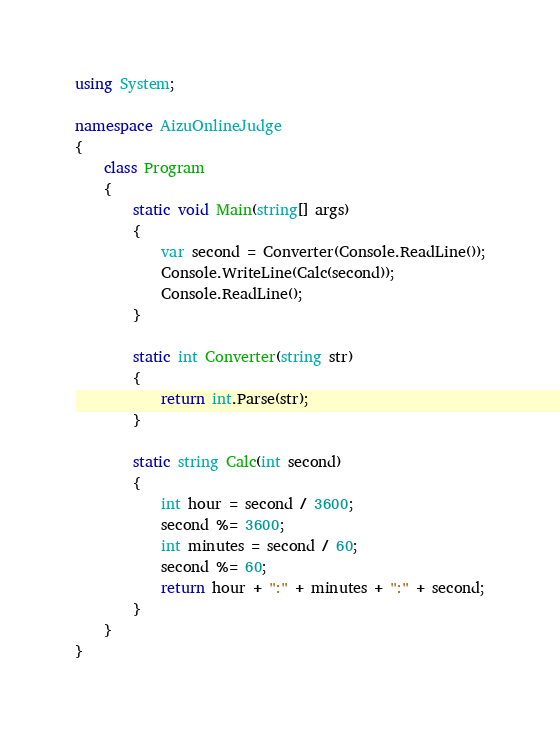Convert code to text. <code><loc_0><loc_0><loc_500><loc_500><_C#_>using System;

namespace AizuOnlineJudge
{
    class Program
    {
        static void Main(string[] args)
        {
            var second = Converter(Console.ReadLine());
            Console.WriteLine(Calc(second));
            Console.ReadLine();
        }

        static int Converter(string str)
        {
            return int.Parse(str);
        }

        static string Calc(int second)
        {
            int hour = second / 3600;
            second %= 3600;
            int minutes = second / 60;
            second %= 60;
            return hour + ":" + minutes + ":" + second;
        }
    }
}

</code> 